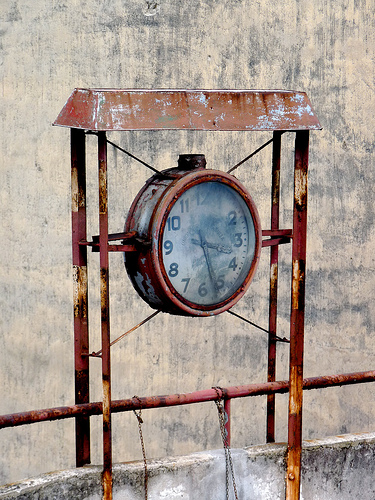Please provide a short description for this region: [0.45, 0.37, 0.63, 0.61]. The clock face here shows bold, black Arabic numerals which are slightly faded but remain legible, giving a classic style to the timepiece. 